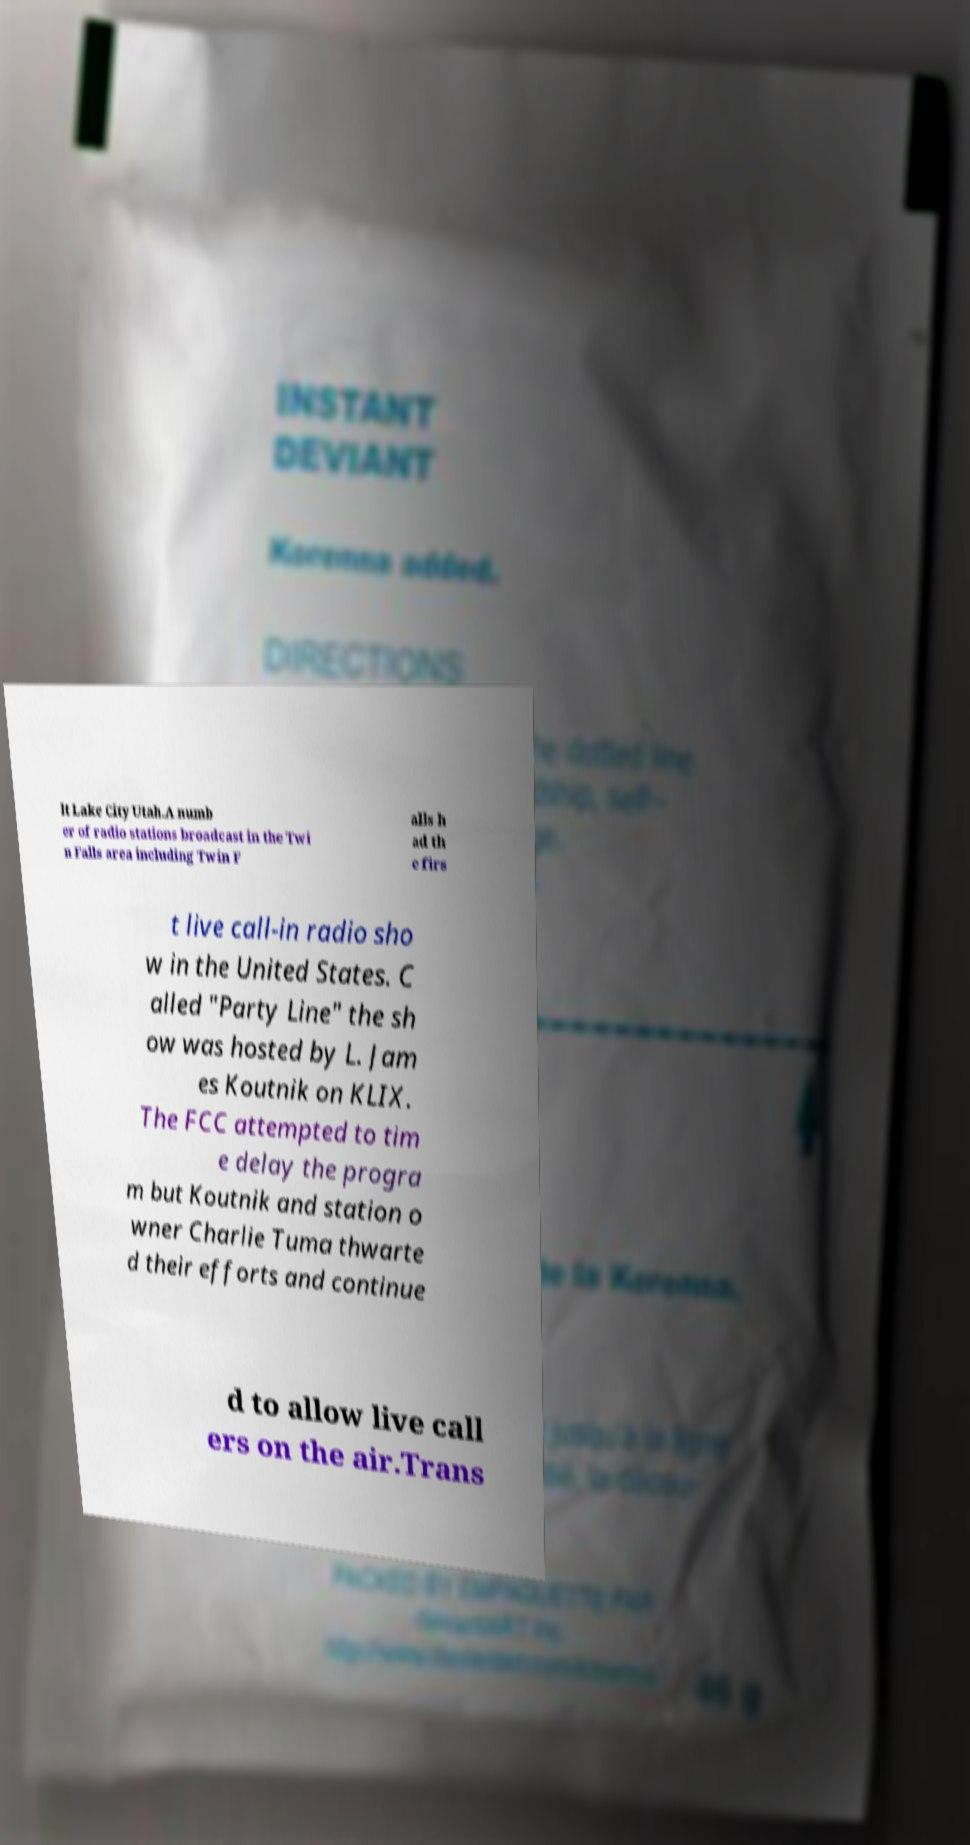Please read and relay the text visible in this image. What does it say? lt Lake City Utah.A numb er of radio stations broadcast in the Twi n Falls area including Twin F alls h ad th e firs t live call-in radio sho w in the United States. C alled "Party Line" the sh ow was hosted by L. Jam es Koutnik on KLIX. The FCC attempted to tim e delay the progra m but Koutnik and station o wner Charlie Tuma thwarte d their efforts and continue d to allow live call ers on the air.Trans 